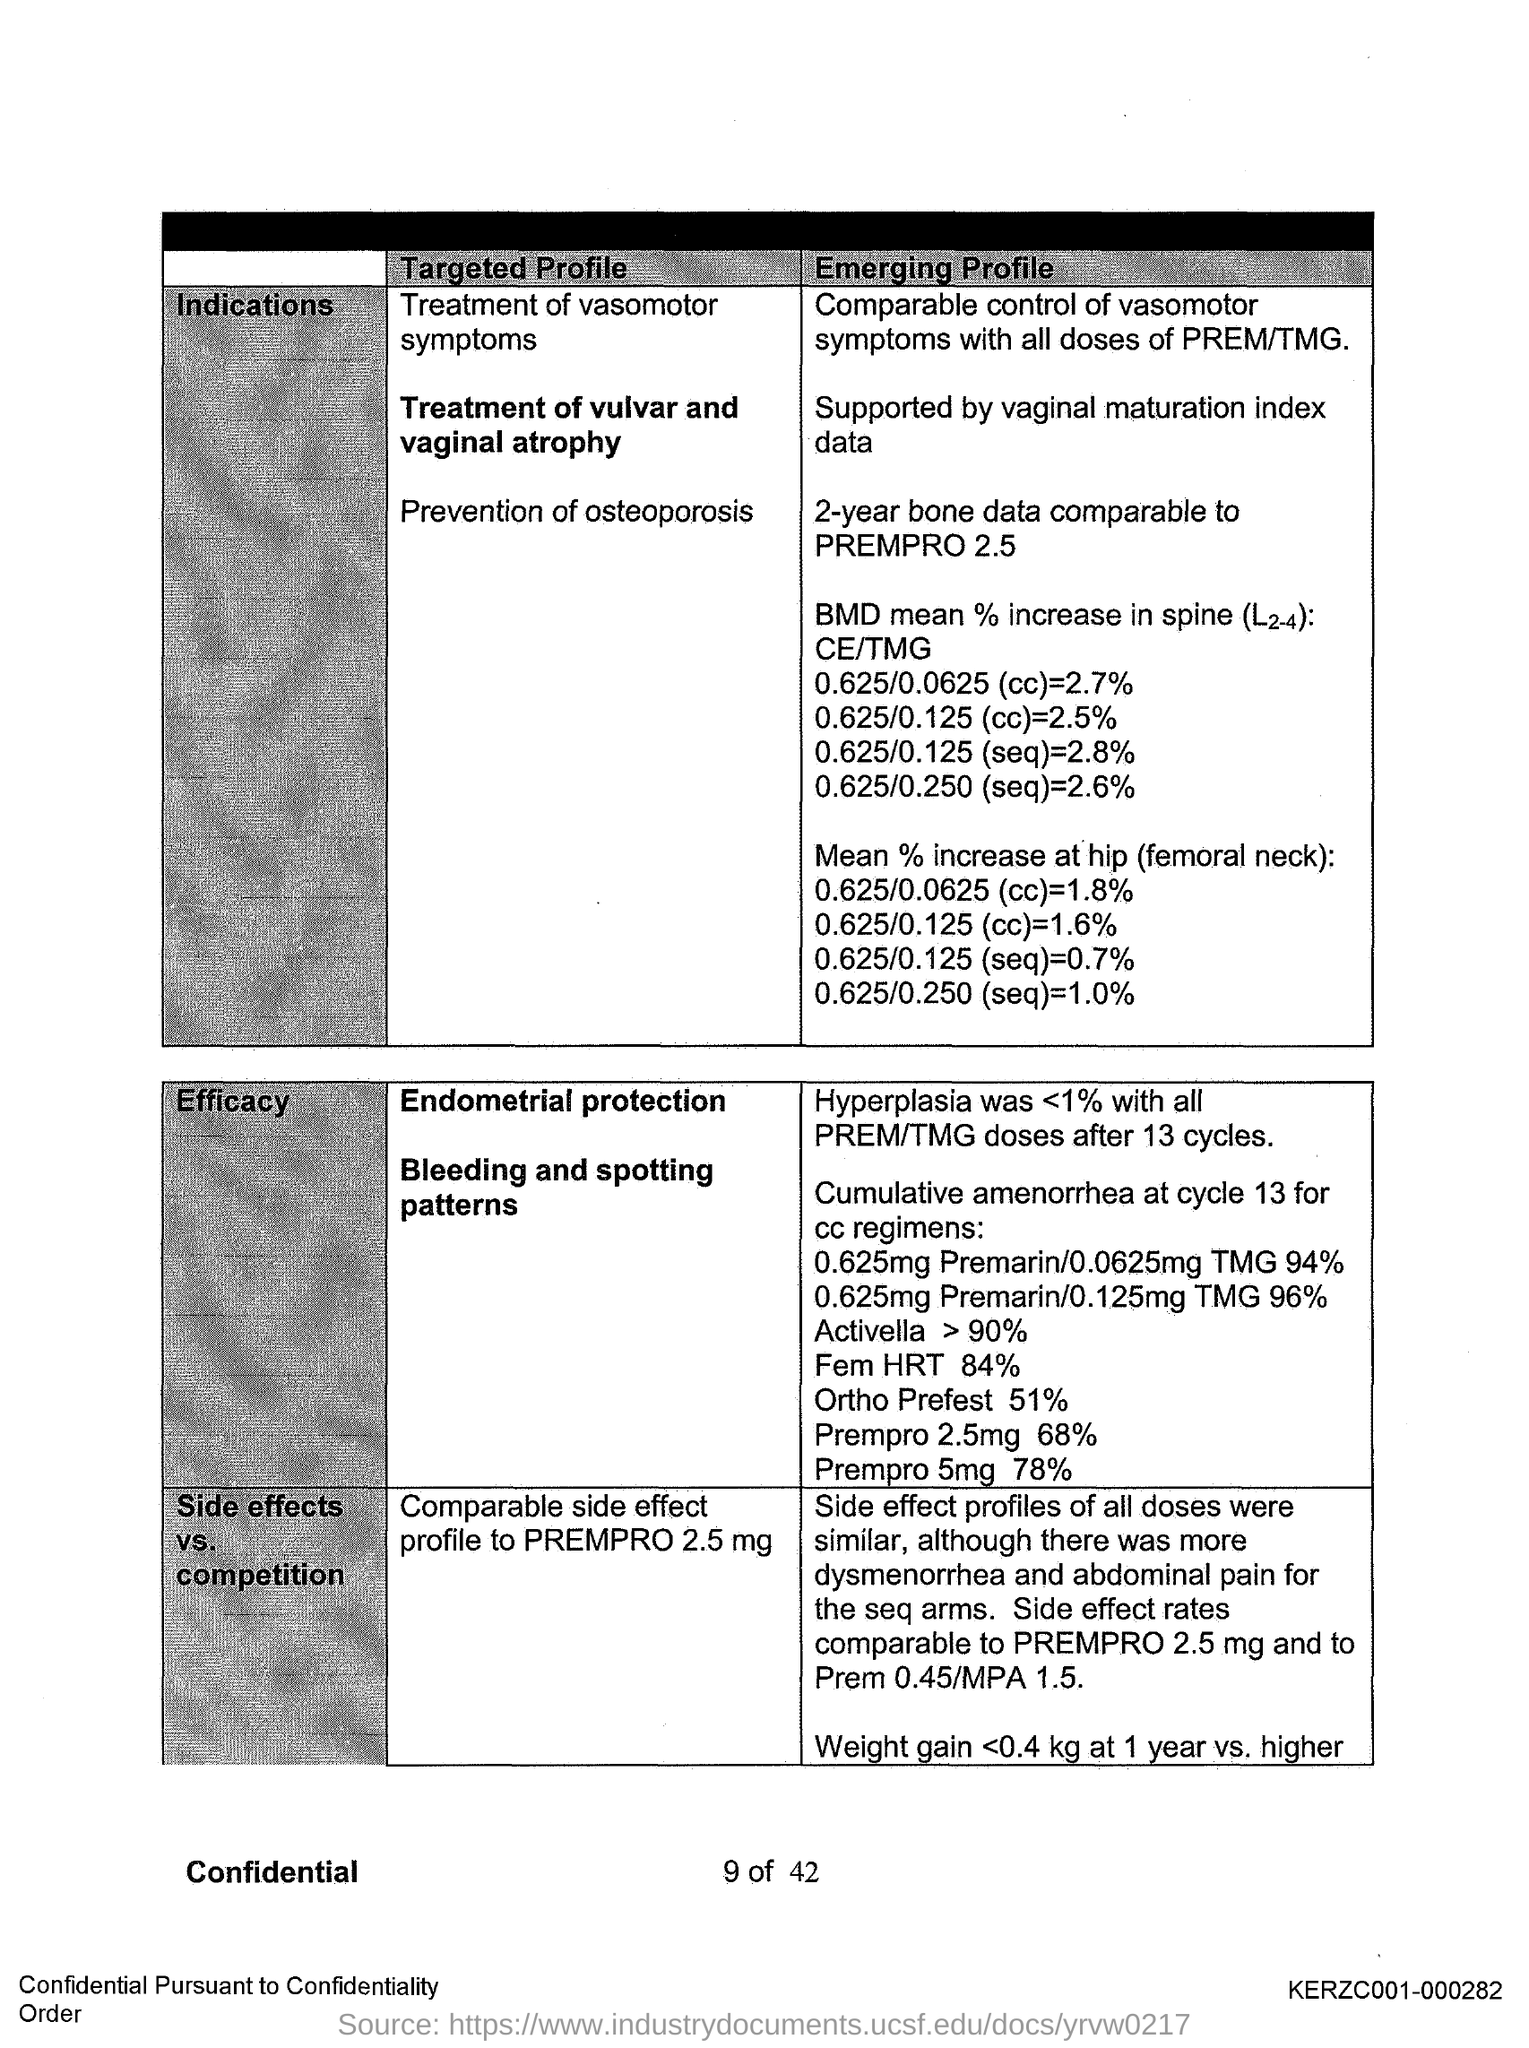Point out several critical features in this image. The code number KERZC001-000282 is written on the right bottom side of the page. The mean percent increase at the hip (femoral neck) was calculated to be 0.625/0.125, resulting in a range of 0.7%. In cycle 13, the cumulative amenorrhea at which the cycle was taken for CC regimens was reached. The heading for the second column of the first table is "Targeted profile. The "Mean % increase at hip (femoral neck): 0.625/0.125 (cc)" is 1.6%. 